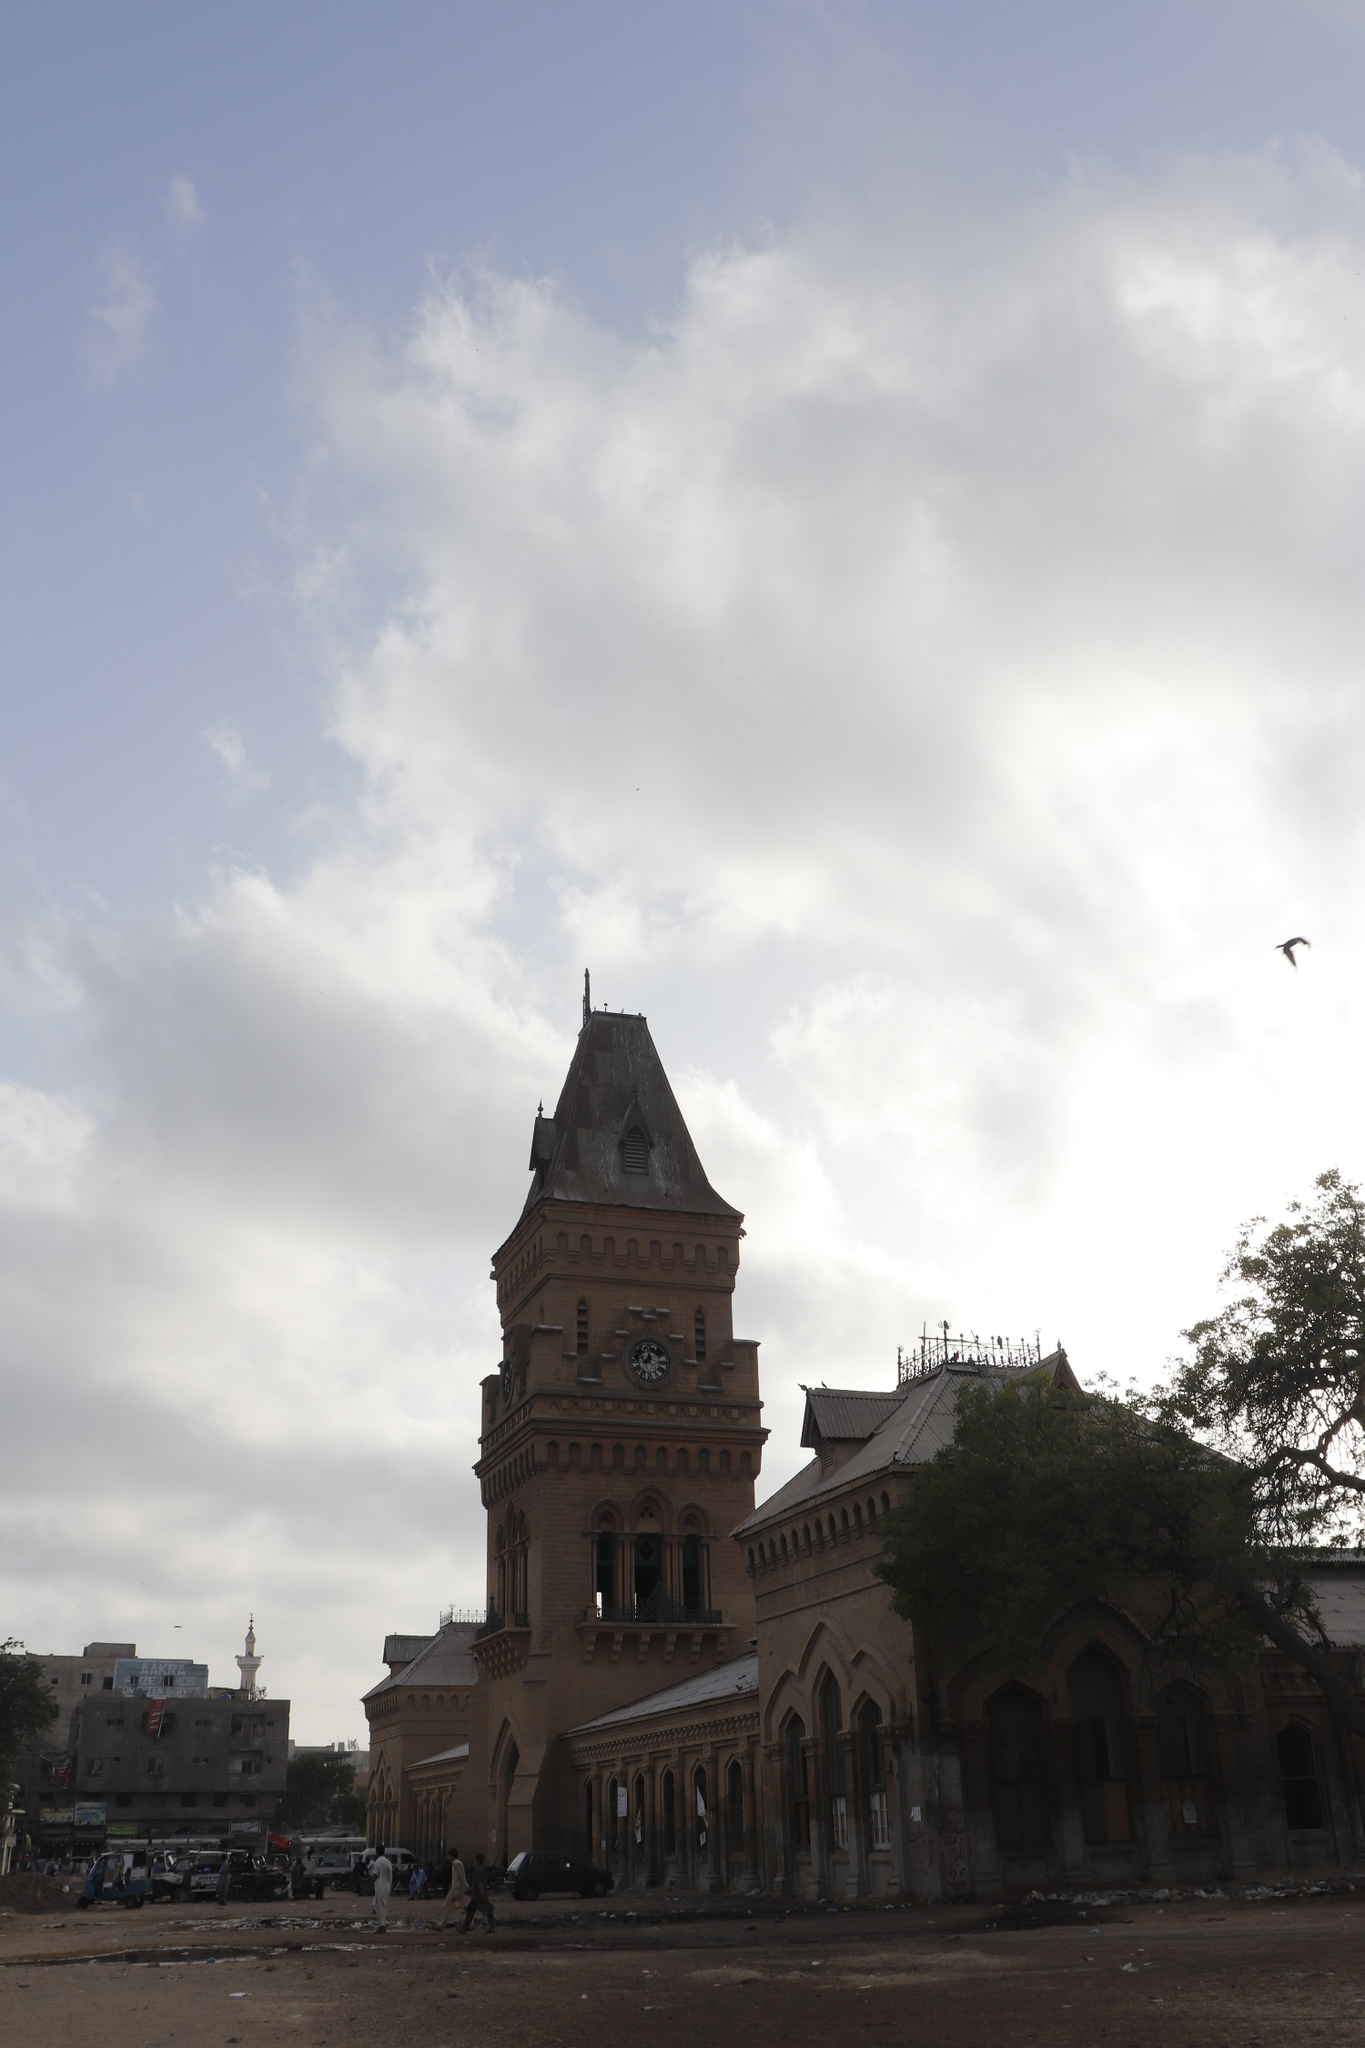What historical significance does the Empress Market hold? The Empress Market, inaugurated in 1889 during British colonial rule, stands as one of Karachi's oldest and most significant marketplaces. Named to commemorate Queen Victoria, the Empress of India, the market embodies colonial history and architecture. Over the years, it has transformed from a symbol of colonial power to a bustling hub of local trade and commerce. The market offers a vivid snapshot of Karachi's cultural diversity, selling an array of goods from fresh produce to exotic spices. Its architectural style, with Gothic influences, reflects the era's aesthetic, blending historical charm with contemporary vibrancy. 